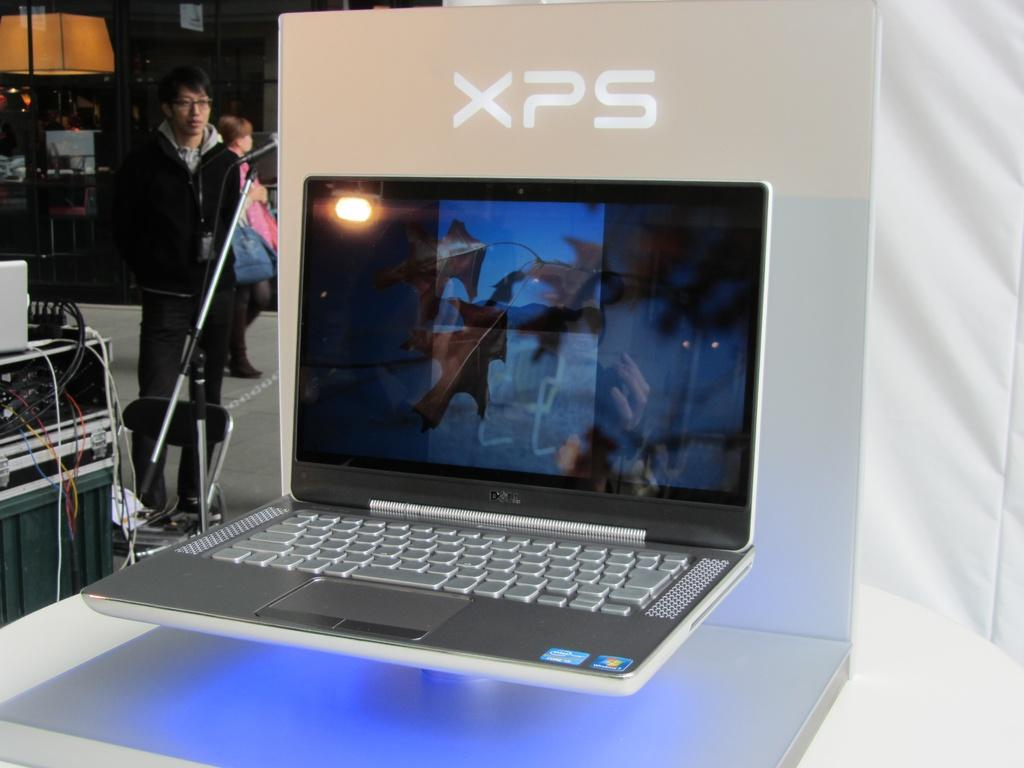<image>
Relay a brief, clear account of the picture shown. A dell display for the XPS model of computers.. 